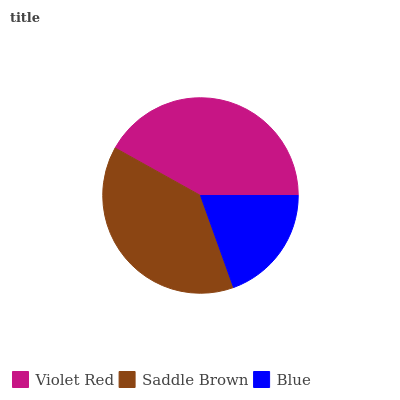Is Blue the minimum?
Answer yes or no. Yes. Is Violet Red the maximum?
Answer yes or no. Yes. Is Saddle Brown the minimum?
Answer yes or no. No. Is Saddle Brown the maximum?
Answer yes or no. No. Is Violet Red greater than Saddle Brown?
Answer yes or no. Yes. Is Saddle Brown less than Violet Red?
Answer yes or no. Yes. Is Saddle Brown greater than Violet Red?
Answer yes or no. No. Is Violet Red less than Saddle Brown?
Answer yes or no. No. Is Saddle Brown the high median?
Answer yes or no. Yes. Is Saddle Brown the low median?
Answer yes or no. Yes. Is Blue the high median?
Answer yes or no. No. Is Blue the low median?
Answer yes or no. No. 